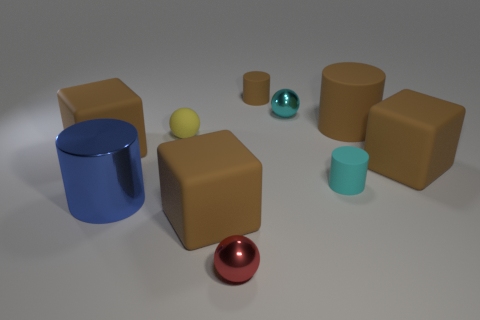How many metal objects are either small brown objects or yellow objects?
Your answer should be compact. 0. Are there the same number of small brown things that are to the left of the metal cylinder and tiny brown rubber cylinders?
Your response must be concise. No. There is a big matte thing that is to the left of the big blue cylinder; is its color the same as the matte sphere?
Your response must be concise. No. There is a cylinder that is both left of the tiny cyan cylinder and on the right side of the red metallic sphere; what is it made of?
Give a very brief answer. Rubber. Is there a tiny cyan matte thing that is on the left side of the brown cube on the left side of the big metallic thing?
Give a very brief answer. No. Is the red sphere made of the same material as the cyan ball?
Make the answer very short. Yes. There is a metal object that is both in front of the big brown matte cylinder and behind the red sphere; what shape is it?
Keep it short and to the point. Cylinder. There is a cylinder in front of the small cylinder in front of the small cyan ball; what size is it?
Your answer should be very brief. Large. What number of red objects are the same shape as the big blue object?
Make the answer very short. 0. Is the large metallic thing the same color as the big rubber cylinder?
Your response must be concise. No. 